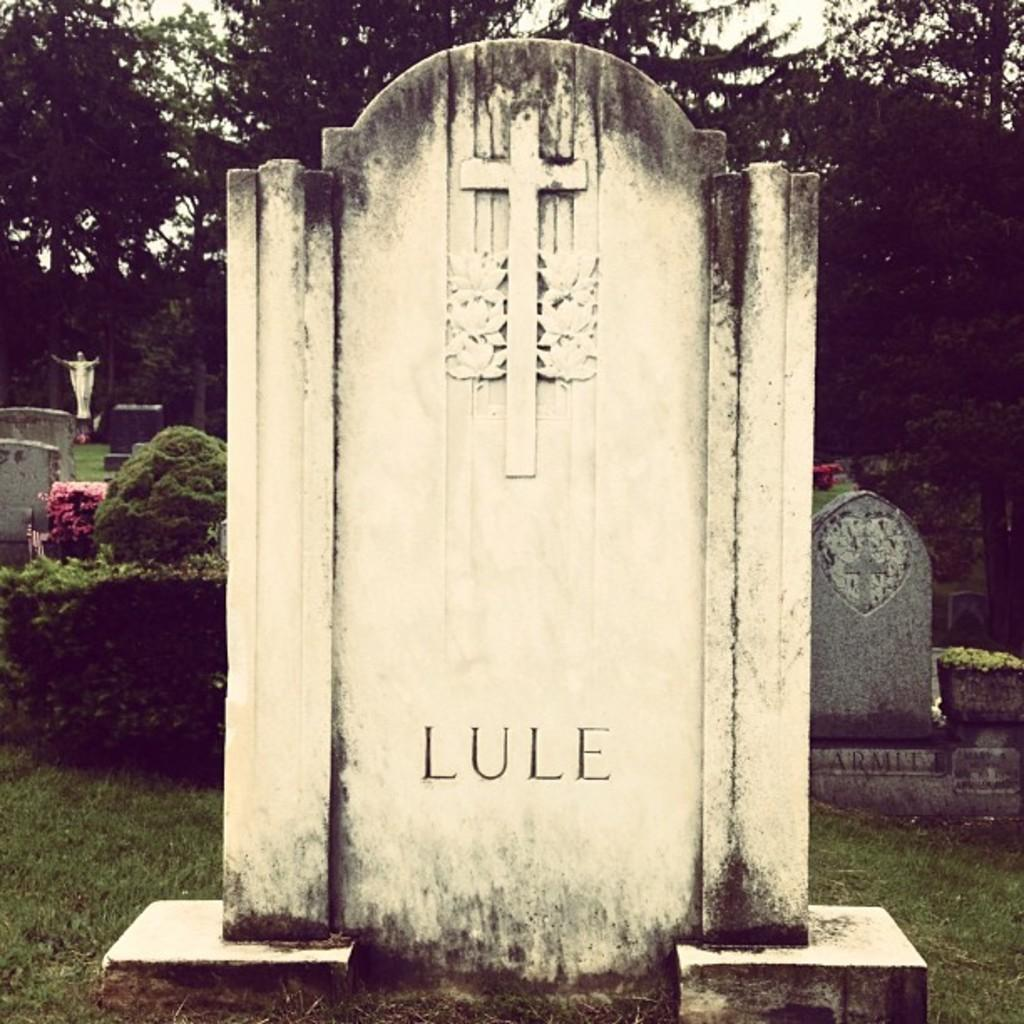What type of location is depicted in the image? There is a graveyard in the image. What is the color and texture of the ground in the image? There is green grass on the ground. What type of vegetation can be seen in the image? There are green trees in the image. What type of guide is present in the image to help visitors navigate the graveyard? There is no guide present in the image; it only shows the graveyard, green grass, and green trees. 